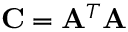<formula> <loc_0><loc_0><loc_500><loc_500>C = A ^ { T } A</formula> 